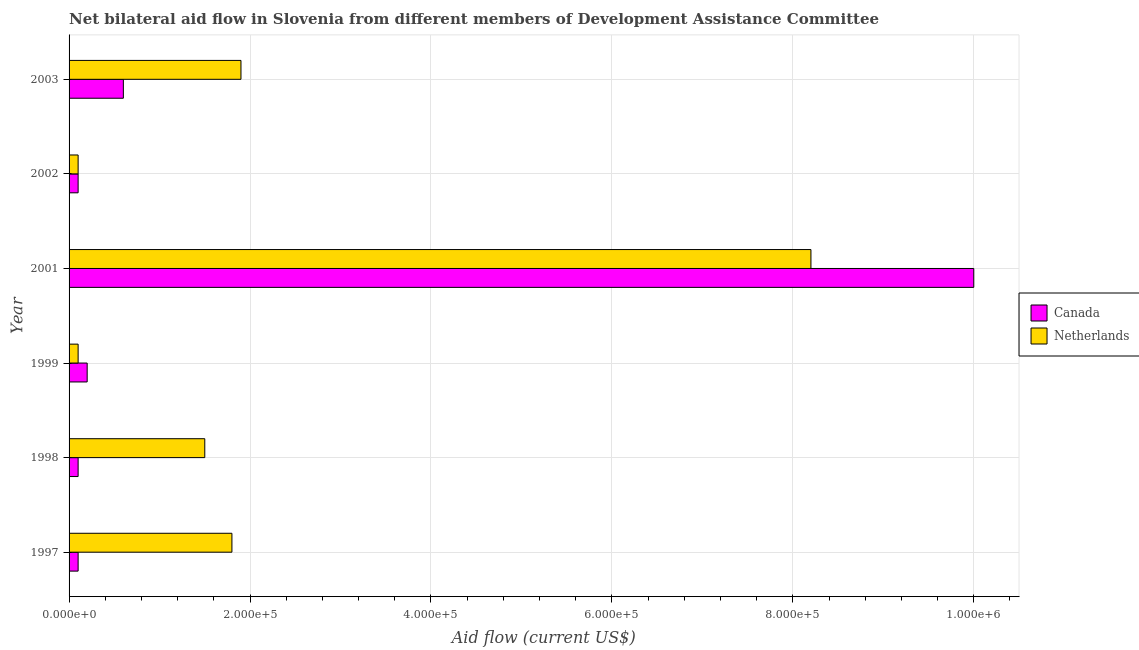Are the number of bars per tick equal to the number of legend labels?
Offer a very short reply. Yes. Are the number of bars on each tick of the Y-axis equal?
Your response must be concise. Yes. How many bars are there on the 1st tick from the bottom?
Offer a terse response. 2. What is the label of the 4th group of bars from the top?
Your response must be concise. 1999. In how many cases, is the number of bars for a given year not equal to the number of legend labels?
Make the answer very short. 0. What is the amount of aid given by canada in 2003?
Provide a short and direct response. 6.00e+04. Across all years, what is the maximum amount of aid given by canada?
Provide a succinct answer. 1.00e+06. Across all years, what is the minimum amount of aid given by netherlands?
Provide a short and direct response. 10000. In which year was the amount of aid given by netherlands maximum?
Provide a short and direct response. 2001. What is the total amount of aid given by canada in the graph?
Give a very brief answer. 1.11e+06. What is the difference between the amount of aid given by netherlands in 2001 and that in 2002?
Your response must be concise. 8.10e+05. What is the difference between the amount of aid given by canada in 2003 and the amount of aid given by netherlands in 2001?
Provide a succinct answer. -7.60e+05. What is the average amount of aid given by canada per year?
Your answer should be very brief. 1.85e+05. In the year 2003, what is the difference between the amount of aid given by canada and amount of aid given by netherlands?
Make the answer very short. -1.30e+05. In how many years, is the amount of aid given by netherlands greater than 480000 US$?
Your answer should be compact. 1. Is the amount of aid given by canada in 1998 less than that in 2001?
Provide a succinct answer. Yes. Is the difference between the amount of aid given by canada in 2002 and 2003 greater than the difference between the amount of aid given by netherlands in 2002 and 2003?
Keep it short and to the point. Yes. What is the difference between the highest and the second highest amount of aid given by canada?
Offer a terse response. 9.40e+05. What is the difference between the highest and the lowest amount of aid given by netherlands?
Offer a terse response. 8.10e+05. In how many years, is the amount of aid given by canada greater than the average amount of aid given by canada taken over all years?
Keep it short and to the point. 1. How many bars are there?
Offer a very short reply. 12. How many years are there in the graph?
Give a very brief answer. 6. What is the difference between two consecutive major ticks on the X-axis?
Give a very brief answer. 2.00e+05. Are the values on the major ticks of X-axis written in scientific E-notation?
Your answer should be very brief. Yes. Does the graph contain any zero values?
Offer a very short reply. No. Where does the legend appear in the graph?
Provide a succinct answer. Center right. How are the legend labels stacked?
Make the answer very short. Vertical. What is the title of the graph?
Ensure brevity in your answer.  Net bilateral aid flow in Slovenia from different members of Development Assistance Committee. Does "Long-term debt" appear as one of the legend labels in the graph?
Your answer should be very brief. No. What is the label or title of the X-axis?
Your response must be concise. Aid flow (current US$). What is the label or title of the Y-axis?
Your response must be concise. Year. What is the Aid flow (current US$) in Netherlands in 1997?
Provide a succinct answer. 1.80e+05. What is the Aid flow (current US$) in Canada in 1998?
Offer a very short reply. 10000. What is the Aid flow (current US$) of Canada in 1999?
Provide a short and direct response. 2.00e+04. What is the Aid flow (current US$) of Netherlands in 1999?
Ensure brevity in your answer.  10000. What is the Aid flow (current US$) of Netherlands in 2001?
Provide a short and direct response. 8.20e+05. What is the Aid flow (current US$) in Canada in 2002?
Make the answer very short. 10000. What is the Aid flow (current US$) in Netherlands in 2002?
Your answer should be compact. 10000. What is the Aid flow (current US$) of Canada in 2003?
Your response must be concise. 6.00e+04. Across all years, what is the maximum Aid flow (current US$) in Canada?
Ensure brevity in your answer.  1.00e+06. Across all years, what is the maximum Aid flow (current US$) in Netherlands?
Your answer should be compact. 8.20e+05. Across all years, what is the minimum Aid flow (current US$) in Canada?
Give a very brief answer. 10000. What is the total Aid flow (current US$) of Canada in the graph?
Your response must be concise. 1.11e+06. What is the total Aid flow (current US$) of Netherlands in the graph?
Offer a very short reply. 1.36e+06. What is the difference between the Aid flow (current US$) of Canada in 1997 and that in 1998?
Provide a short and direct response. 0. What is the difference between the Aid flow (current US$) in Netherlands in 1997 and that in 1998?
Provide a succinct answer. 3.00e+04. What is the difference between the Aid flow (current US$) in Netherlands in 1997 and that in 1999?
Provide a succinct answer. 1.70e+05. What is the difference between the Aid flow (current US$) of Canada in 1997 and that in 2001?
Give a very brief answer. -9.90e+05. What is the difference between the Aid flow (current US$) of Netherlands in 1997 and that in 2001?
Give a very brief answer. -6.40e+05. What is the difference between the Aid flow (current US$) of Canada in 1997 and that in 2003?
Give a very brief answer. -5.00e+04. What is the difference between the Aid flow (current US$) in Canada in 1998 and that in 1999?
Your response must be concise. -10000. What is the difference between the Aid flow (current US$) of Canada in 1998 and that in 2001?
Make the answer very short. -9.90e+05. What is the difference between the Aid flow (current US$) in Netherlands in 1998 and that in 2001?
Provide a short and direct response. -6.70e+05. What is the difference between the Aid flow (current US$) of Netherlands in 1998 and that in 2002?
Your response must be concise. 1.40e+05. What is the difference between the Aid flow (current US$) in Netherlands in 1998 and that in 2003?
Give a very brief answer. -4.00e+04. What is the difference between the Aid flow (current US$) of Canada in 1999 and that in 2001?
Ensure brevity in your answer.  -9.80e+05. What is the difference between the Aid flow (current US$) in Netherlands in 1999 and that in 2001?
Your response must be concise. -8.10e+05. What is the difference between the Aid flow (current US$) in Canada in 1999 and that in 2002?
Ensure brevity in your answer.  10000. What is the difference between the Aid flow (current US$) in Canada in 1999 and that in 2003?
Your response must be concise. -4.00e+04. What is the difference between the Aid flow (current US$) of Netherlands in 1999 and that in 2003?
Offer a terse response. -1.80e+05. What is the difference between the Aid flow (current US$) of Canada in 2001 and that in 2002?
Provide a succinct answer. 9.90e+05. What is the difference between the Aid flow (current US$) in Netherlands in 2001 and that in 2002?
Provide a short and direct response. 8.10e+05. What is the difference between the Aid flow (current US$) of Canada in 2001 and that in 2003?
Offer a very short reply. 9.40e+05. What is the difference between the Aid flow (current US$) in Netherlands in 2001 and that in 2003?
Your response must be concise. 6.30e+05. What is the difference between the Aid flow (current US$) in Netherlands in 2002 and that in 2003?
Your response must be concise. -1.80e+05. What is the difference between the Aid flow (current US$) of Canada in 1997 and the Aid flow (current US$) of Netherlands in 1998?
Give a very brief answer. -1.40e+05. What is the difference between the Aid flow (current US$) of Canada in 1997 and the Aid flow (current US$) of Netherlands in 2001?
Ensure brevity in your answer.  -8.10e+05. What is the difference between the Aid flow (current US$) of Canada in 1997 and the Aid flow (current US$) of Netherlands in 2003?
Your response must be concise. -1.80e+05. What is the difference between the Aid flow (current US$) in Canada in 1998 and the Aid flow (current US$) in Netherlands in 2001?
Provide a succinct answer. -8.10e+05. What is the difference between the Aid flow (current US$) in Canada in 1999 and the Aid flow (current US$) in Netherlands in 2001?
Make the answer very short. -8.00e+05. What is the difference between the Aid flow (current US$) in Canada in 1999 and the Aid flow (current US$) in Netherlands in 2003?
Provide a short and direct response. -1.70e+05. What is the difference between the Aid flow (current US$) in Canada in 2001 and the Aid flow (current US$) in Netherlands in 2002?
Your response must be concise. 9.90e+05. What is the difference between the Aid flow (current US$) in Canada in 2001 and the Aid flow (current US$) in Netherlands in 2003?
Keep it short and to the point. 8.10e+05. What is the average Aid flow (current US$) in Canada per year?
Make the answer very short. 1.85e+05. What is the average Aid flow (current US$) of Netherlands per year?
Ensure brevity in your answer.  2.27e+05. In the year 1999, what is the difference between the Aid flow (current US$) of Canada and Aid flow (current US$) of Netherlands?
Offer a terse response. 10000. In the year 2001, what is the difference between the Aid flow (current US$) of Canada and Aid flow (current US$) of Netherlands?
Your answer should be very brief. 1.80e+05. In the year 2003, what is the difference between the Aid flow (current US$) in Canada and Aid flow (current US$) in Netherlands?
Your response must be concise. -1.30e+05. What is the ratio of the Aid flow (current US$) of Canada in 1997 to that in 2001?
Ensure brevity in your answer.  0.01. What is the ratio of the Aid flow (current US$) of Netherlands in 1997 to that in 2001?
Provide a short and direct response. 0.22. What is the ratio of the Aid flow (current US$) in Netherlands in 1997 to that in 2002?
Make the answer very short. 18. What is the ratio of the Aid flow (current US$) in Canada in 1998 to that in 1999?
Provide a short and direct response. 0.5. What is the ratio of the Aid flow (current US$) of Canada in 1998 to that in 2001?
Ensure brevity in your answer.  0.01. What is the ratio of the Aid flow (current US$) in Netherlands in 1998 to that in 2001?
Provide a succinct answer. 0.18. What is the ratio of the Aid flow (current US$) in Netherlands in 1998 to that in 2003?
Give a very brief answer. 0.79. What is the ratio of the Aid flow (current US$) in Canada in 1999 to that in 2001?
Your answer should be compact. 0.02. What is the ratio of the Aid flow (current US$) in Netherlands in 1999 to that in 2001?
Offer a terse response. 0.01. What is the ratio of the Aid flow (current US$) of Netherlands in 1999 to that in 2002?
Your answer should be compact. 1. What is the ratio of the Aid flow (current US$) of Netherlands in 1999 to that in 2003?
Your response must be concise. 0.05. What is the ratio of the Aid flow (current US$) of Netherlands in 2001 to that in 2002?
Keep it short and to the point. 82. What is the ratio of the Aid flow (current US$) in Canada in 2001 to that in 2003?
Your answer should be very brief. 16.67. What is the ratio of the Aid flow (current US$) in Netherlands in 2001 to that in 2003?
Your answer should be very brief. 4.32. What is the ratio of the Aid flow (current US$) of Canada in 2002 to that in 2003?
Offer a terse response. 0.17. What is the ratio of the Aid flow (current US$) of Netherlands in 2002 to that in 2003?
Make the answer very short. 0.05. What is the difference between the highest and the second highest Aid flow (current US$) in Canada?
Offer a very short reply. 9.40e+05. What is the difference between the highest and the second highest Aid flow (current US$) of Netherlands?
Give a very brief answer. 6.30e+05. What is the difference between the highest and the lowest Aid flow (current US$) in Canada?
Ensure brevity in your answer.  9.90e+05. What is the difference between the highest and the lowest Aid flow (current US$) of Netherlands?
Make the answer very short. 8.10e+05. 